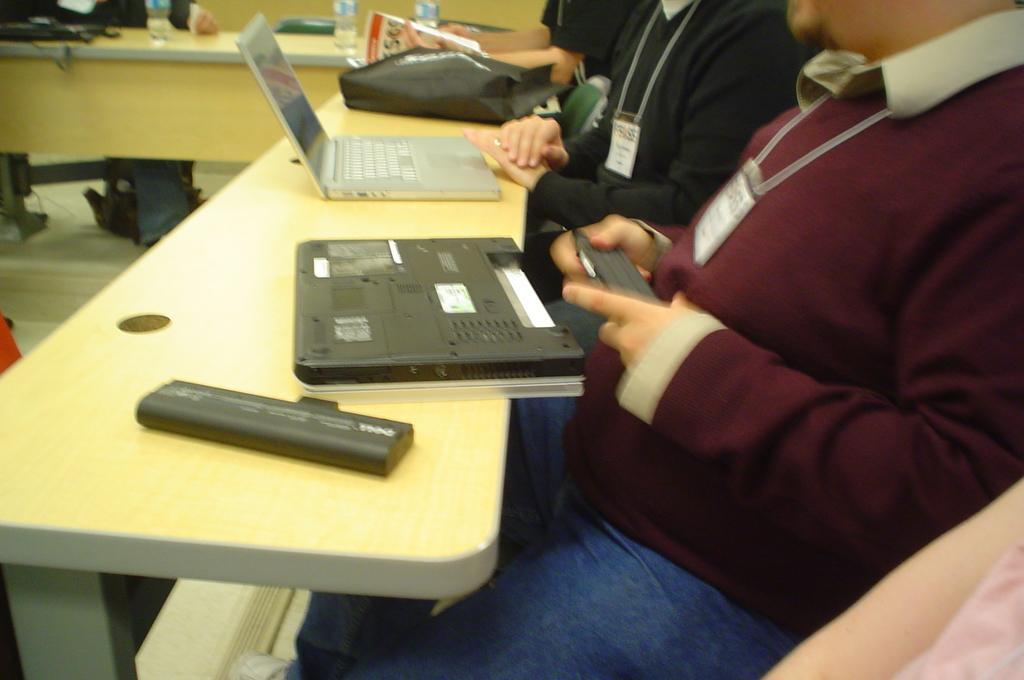Describe this image in one or two sentences. In this picture there are three people sitting on the chair. There is a laptop, bag, bottle and few other objects on the table. 